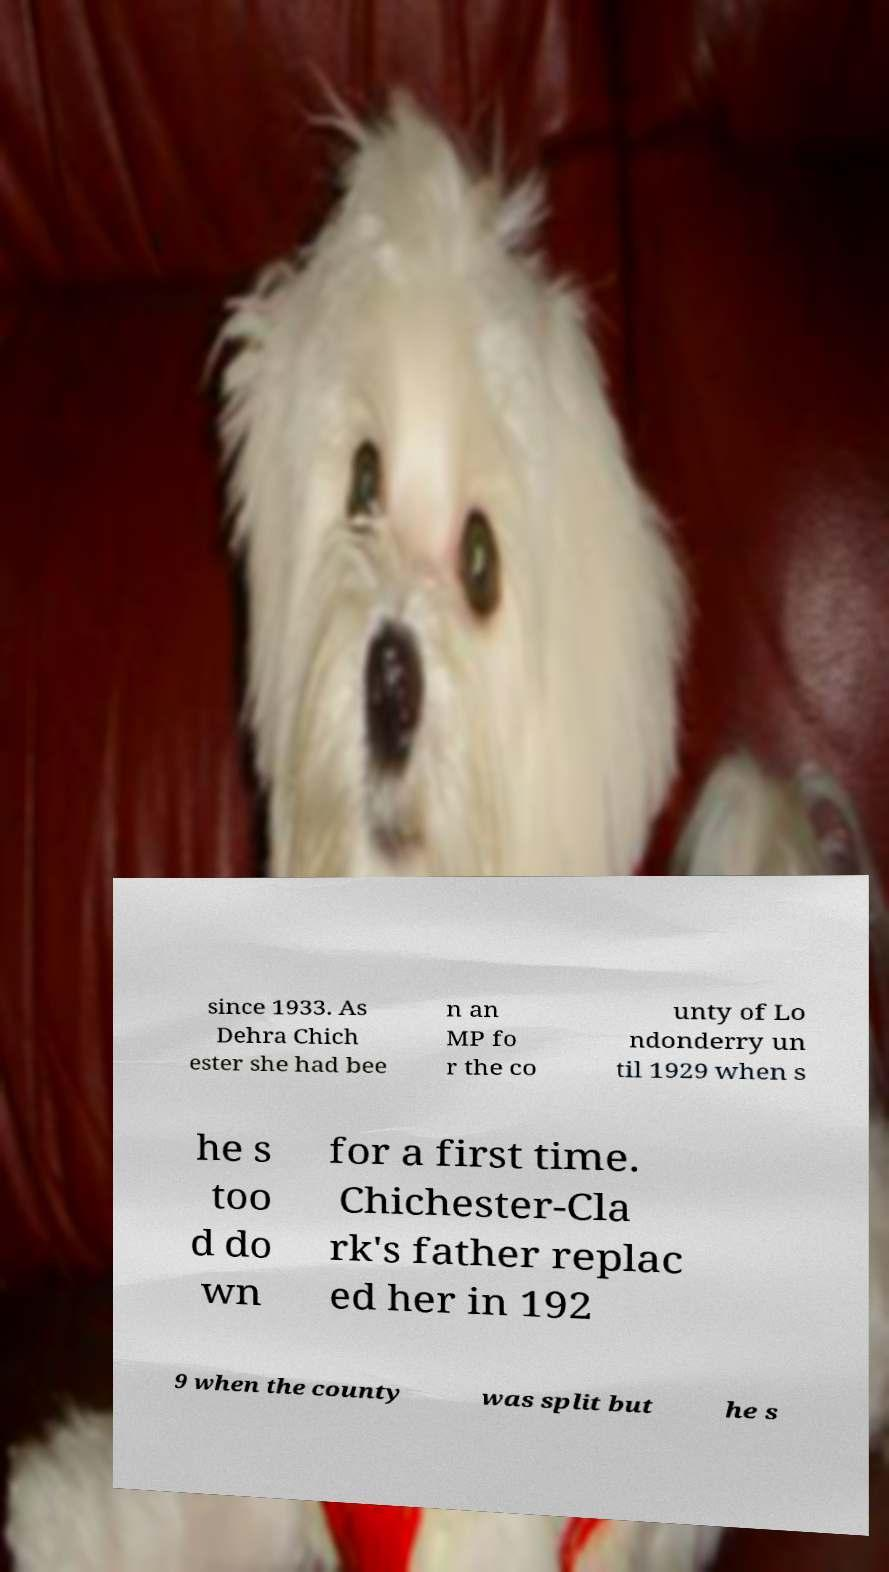For documentation purposes, I need the text within this image transcribed. Could you provide that? since 1933. As Dehra Chich ester she had bee n an MP fo r the co unty of Lo ndonderry un til 1929 when s he s too d do wn for a first time. Chichester-Cla rk's father replac ed her in 192 9 when the county was split but he s 